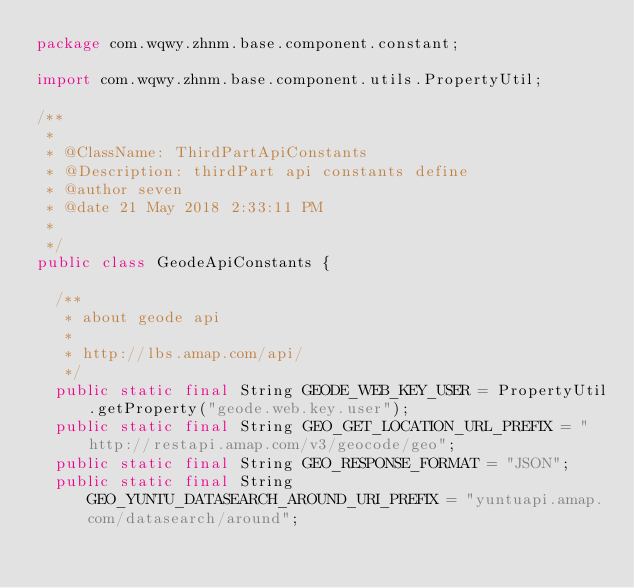<code> <loc_0><loc_0><loc_500><loc_500><_Java_>package com.wqwy.zhnm.base.component.constant;

import com.wqwy.zhnm.base.component.utils.PropertyUtil;

/**
 * 
 * @ClassName: ThirdPartApiConstants  
 * @Description: thirdPart api constants define  
 * @author seven  
 * @date 21 May 2018 2:33:11 PM  
 *
 */
public class GeodeApiConstants {

	/**
	 * about geode api
	 * 
	 * http://lbs.amap.com/api/
	 */
	public static final String GEODE_WEB_KEY_USER = PropertyUtil.getProperty("geode.web.key.user");
	public static final String GEO_GET_LOCATION_URL_PREFIX = "http://restapi.amap.com/v3/geocode/geo";
	public static final String GEO_RESPONSE_FORMAT = "JSON";
	public static final String GEO_YUNTU_DATASEARCH_AROUND_URI_PREFIX = "yuntuapi.amap.com/datasearch/around";</code> 